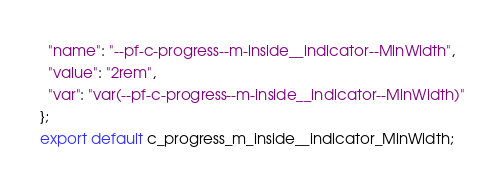Convert code to text. <code><loc_0><loc_0><loc_500><loc_500><_TypeScript_>  "name": "--pf-c-progress--m-inside__indicator--MinWidth",
  "value": "2rem",
  "var": "var(--pf-c-progress--m-inside__indicator--MinWidth)"
};
export default c_progress_m_inside__indicator_MinWidth;</code> 